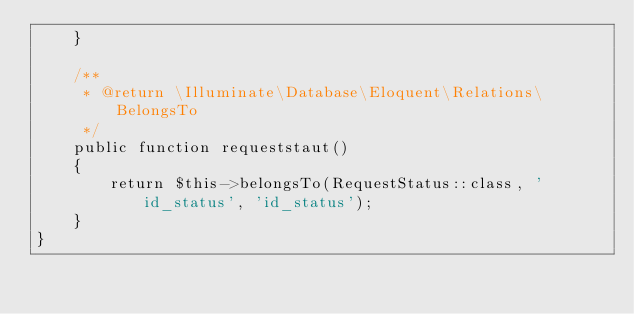Convert code to text. <code><loc_0><loc_0><loc_500><loc_500><_PHP_>    }

    /**
     * @return \Illuminate\Database\Eloquent\Relations\BelongsTo
     */
    public function requeststaut()
    {
        return $this->belongsTo(RequestStatus::class, 'id_status', 'id_status');
    }
}
</code> 